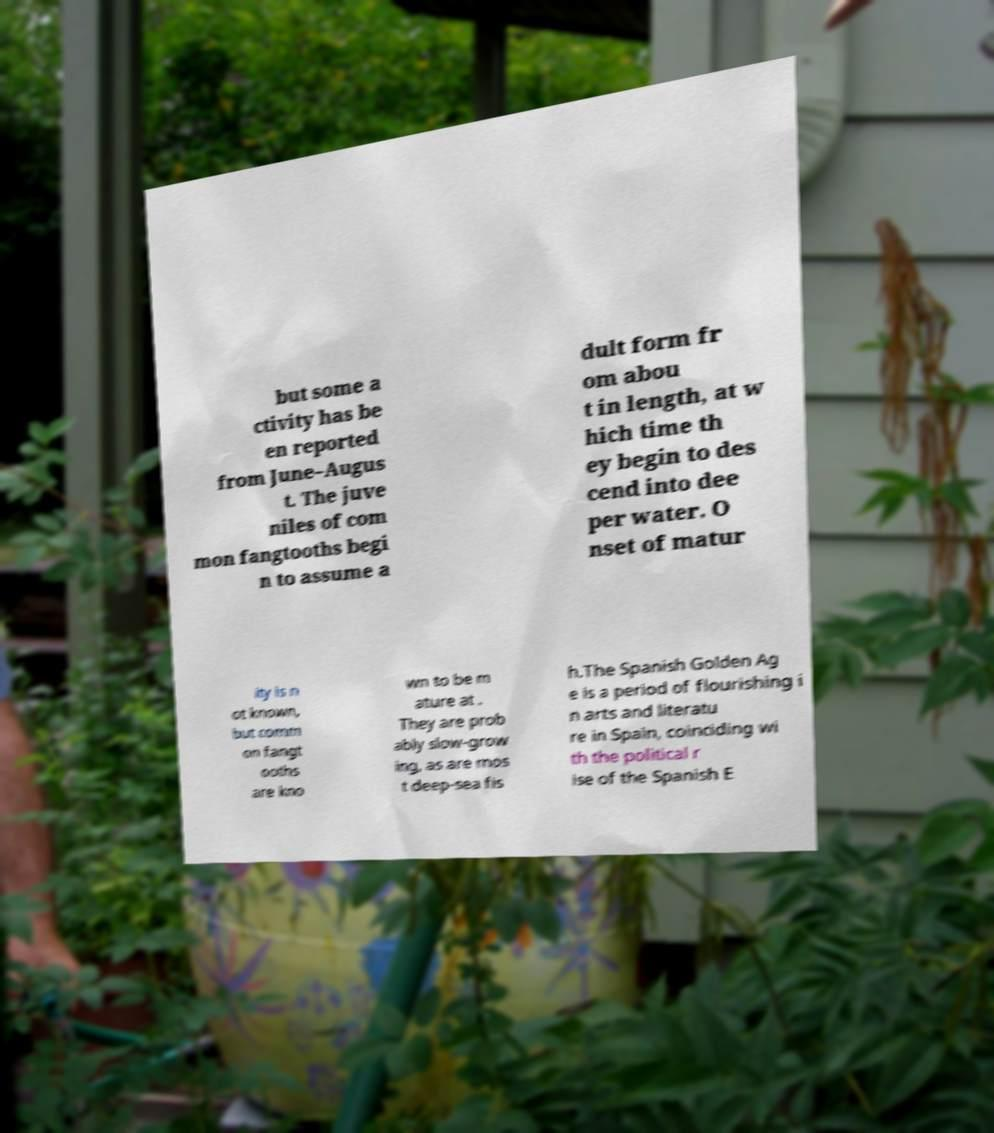Can you accurately transcribe the text from the provided image for me? but some a ctivity has be en reported from June–Augus t. The juve niles of com mon fangtooths begi n to assume a dult form fr om abou t in length, at w hich time th ey begin to des cend into dee per water. O nset of matur ity is n ot known, but comm on fangt ooths are kno wn to be m ature at . They are prob ably slow-grow ing, as are mos t deep-sea fis h.The Spanish Golden Ag e is a period of flourishing i n arts and literatu re in Spain, coinciding wi th the political r ise of the Spanish E 